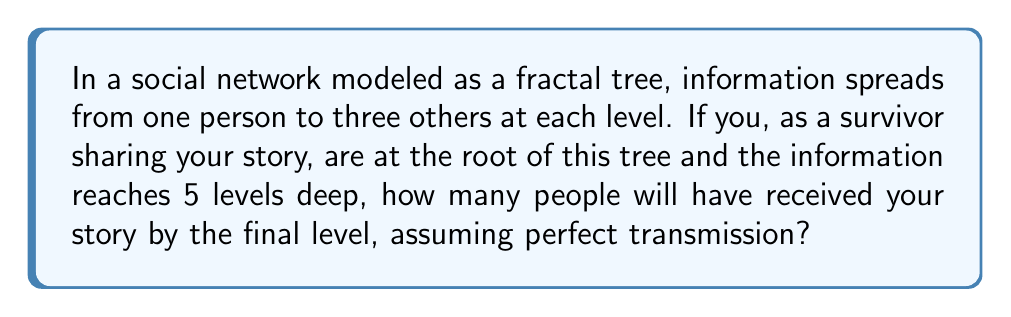Can you solve this math problem? Let's approach this step-by-step using the properties of fractal trees and geometric series:

1) In this fractal model, each node (person) spreads information to 3 new nodes in the next level.

2) The number of people reached at each level forms a geometric sequence:
   Level 0 (root): $1 = 3^0$
   Level 1: $3 = 3^1$
   Level 2: $9 = 3^2$
   Level 3: $27 = 3^3$
   Level 4: $81 = 3^4$
   Level 5: $243 = 3^5$

3) To find the total number of people reached by the final level, we need to sum this geometric sequence from $3^0$ to $3^5$.

4) The sum of a geometric sequence is given by the formula:

   $$S_n = \frac{a(1-r^{n+1})}{1-r}$$

   Where $a$ is the first term, $r$ is the common ratio, and $n$ is the number of terms.

5) In our case:
   $a = 1$, $r = 3$, $n = 5$

6) Plugging these values into the formula:

   $$S_5 = \frac{1(1-3^{6})}{1-3} = \frac{1-729}{-2} = \frac{728}{2} = 364$$

Therefore, by the final level, your story will have reached 364 people.
Answer: 364 people 